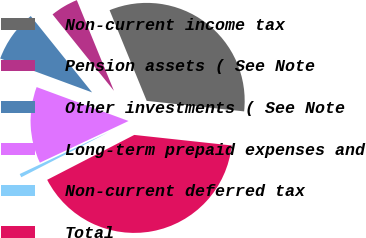Convert chart. <chart><loc_0><loc_0><loc_500><loc_500><pie_chart><fcel>Non-current income tax<fcel>Pension assets ( See Note<fcel>Other investments ( See Note<fcel>Long-term prepaid expenses and<fcel>Non-current deferred tax<fcel>Total<nl><fcel>32.9%<fcel>4.59%<fcel>8.6%<fcel>12.62%<fcel>0.58%<fcel>40.71%<nl></chart> 